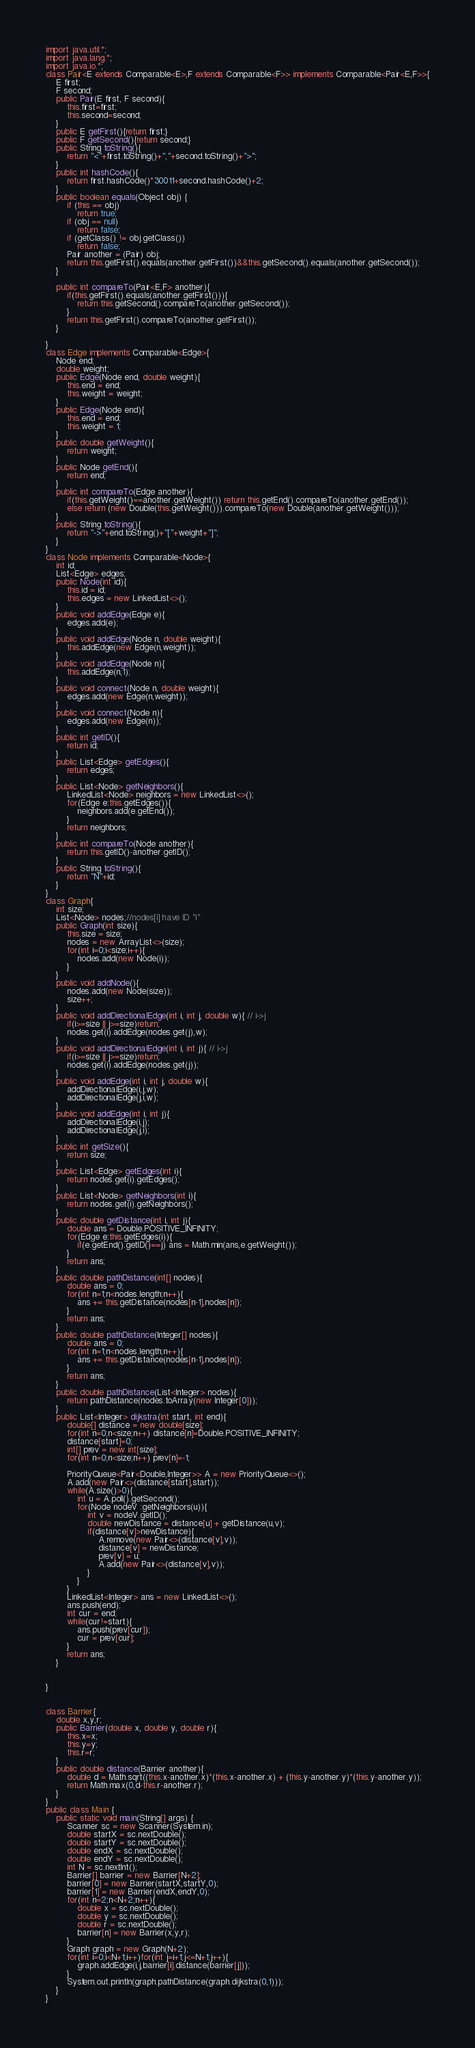<code> <loc_0><loc_0><loc_500><loc_500><_Java_>import java.util.*;
import java.lang.*;
import java.io.*;
class Pair<E extends Comparable<E>,F extends Comparable<F>> implements Comparable<Pair<E,F>>{
    E first;
    F second;
    public Pair(E first, F second){
        this.first=first;
        this.second=second;
    }
    public E getFirst(){return first;}
    public F getSecond(){return second;}
    public String toString(){
        return "<"+first.toString()+","+second.toString()+">";
    }
    public int hashCode(){
        return first.hashCode()*30011+second.hashCode()+2;
    }
    public boolean equals(Object obj) {
        if (this == obj)
            return true;
        if (obj == null)
            return false;
        if (getClass() != obj.getClass())
            return false;
        Pair another = (Pair) obj;
        return this.getFirst().equals(another.getFirst())&&this.getSecond().equals(another.getSecond());
    }
    
    public int compareTo(Pair<E,F> another){
        if(this.getFirst().equals(another.getFirst())){
        	return this.getSecond().compareTo(another.getSecond());
        }
        return this.getFirst().compareTo(another.getFirst());
    }
    
}
class Edge implements Comparable<Edge>{
    Node end;
    double weight;
    public Edge(Node end, double weight){
        this.end = end;
        this.weight = weight;
    }
    public Edge(Node end){
        this.end = end;
        this.weight = 1;
    }
    public double getWeight(){
        return weight;
    }
    public Node getEnd(){
        return end;
    }
    public int compareTo(Edge another){
        if(this.getWeight()==another.getWeight()) return this.getEnd().compareTo(another.getEnd());
        else return (new Double(this.getWeight())).compareTo(new Double(another.getWeight()));
    }
    public String toString(){
        return "->"+end.toString()+"["+weight+"]";
    }
}
class Node implements Comparable<Node>{
    int id;
    List<Edge> edges;
    public Node(int id){
        this.id = id;
        this.edges = new LinkedList<>();
    }
    public void addEdge(Edge e){
        edges.add(e);
    }
    public void addEdge(Node n, double weight){
        this.addEdge(new Edge(n,weight));
    }
    public void addEdge(Node n){
        this.addEdge(n,1);
    }
    public void connect(Node n, double weight){
        edges.add(new Edge(n,weight));
    }
    public void connect(Node n){
        edges.add(new Edge(n));
    }
    public int getID(){
        return id;
    }
    public List<Edge> getEdges(){
        return edges;
    }
    public List<Node> getNeighbors(){
        LinkedList<Node> neighbors = new LinkedList<>();
        for(Edge e:this.getEdges()){
        	neighbors.add(e.getEnd());
        }
        return neighbors;
    }
    public int compareTo(Node another){
        return this.getID()-another.getID();
    }
    public String toString(){
        return "N"+id;
    }
}
class Graph{
    int size;
    List<Node> nodes;//nodes[i] have ID "i"
    public Graph(int size){
        this.size = size;
        nodes = new ArrayList<>(size);
        for(int i=0;i<size;i++){
        	nodes.add(new Node(i));
        }
    }
    public void addNode(){
        nodes.add(new Node(size));
        size++;
    }
    public void addDirectionalEdge(int i, int j, double w){ // i->j
        if(i>=size || j>=size)return;
        nodes.get(i).addEdge(nodes.get(j),w);
    }
    public void addDirectionalEdge(int i, int j){ // i->j
        if(i>=size || j>=size)return;
        nodes.get(i).addEdge(nodes.get(j));
    }
    public void addEdge(int i, int j, double w){
        addDirectionalEdge(i,j,w);
        addDirectionalEdge(j,i,w);
    }
    public void addEdge(int i, int j){
        addDirectionalEdge(i,j);
        addDirectionalEdge(j,i);
    }
    public int getSize(){
        return size;
    }
    public List<Edge> getEdges(int i){
        return nodes.get(i).getEdges();
    }
    public List<Node> getNeighbors(int i){
        return nodes.get(i).getNeighbors();
    }
    public double getDistance(int i, int j){
        double ans = Double.POSITIVE_INFINITY;
        for(Edge e:this.getEdges(i)){
        	if(e.getEnd().getID()==j) ans = Math.min(ans,e.getWeight());
        }
        return ans;
    }
    public double pathDistance(int[] nodes){
        double ans = 0;
        for(int n=1;n<nodes.length;n++){
        	ans += this.getDistance(nodes[n-1],nodes[n]);
        }
        return ans;
    }
    public double pathDistance(Integer[] nodes){
        double ans = 0;
        for(int n=1;n<nodes.length;n++){
        	ans += this.getDistance(nodes[n-1],nodes[n]);
        }
        return ans;
    }
    public double pathDistance(List<Integer> nodes){
        return pathDistance(nodes.toArray(new Integer[0]));
    }
    public List<Integer> dijkstra(int start, int end){
        double[] distance = new double[size];
        for(int n=0;n<size;n++) distance[n]=Double.POSITIVE_INFINITY;
        distance[start]=0;
        int[] prev = new int[size];
        for(int n=0;n<size;n++) prev[n]=-1;
        
        PriorityQueue<Pair<Double,Integer>> A = new PriorityQueue<>();
        A.add(new Pair<>(distance[start],start));
        while(A.size()>0){
        	int u = A.poll().getSecond();
        	for(Node nodeV :getNeighbors(u)){
        	    int v = nodeV.getID();
        	    double newDistance = distance[u] + getDistance(u,v);
        	    if(distance[v]>newDistance){
        	        A.remove(new Pair<>(distance[v],v));
        	        distance[v] = newDistance;
        	        prev[v] = u;
        	        A.add(new Pair<>(distance[v],v));
        	    }
        	}
        }
        LinkedList<Integer> ans = new LinkedList<>();
        ans.push(end);
        int cur = end;
        while(cur!=start){
        	ans.push(prev[cur]);
        	cur = prev[cur];
        }
        return ans;
    }
    
    
}


class Barrier{
    double x,y,r;
    public Barrier(double x, double y, double r){
        this.x=x;
        this.y=y;
        this.r=r;
    }
    public double distance(Barrier another){
        double d = Math.sqrt((this.x-another.x)*(this.x-another.x) + (this.y-another.y)*(this.y-another.y));
        return Math.max(0,d-this.r-another.r);
    }
}
public class Main {
    public static void main(String[] args) {
        Scanner sc = new Scanner(System.in);
        double startX = sc.nextDouble();
        double startY = sc.nextDouble();
        double endX = sc.nextDouble();
        double endY = sc.nextDouble();
        int N = sc.nextInt();
        Barrier[] barrier = new Barrier[N+2];
        barrier[0] = new Barrier(startX,startY,0);
        barrier[1] = new Barrier(endX,endY,0);
        for(int n=2;n<N+2;n++){
        	double x = sc.nextDouble();
        	double y = sc.nextDouble();
        	double r = sc.nextDouble();
        	barrier[n] = new Barrier(x,y,r);
        }
        Graph graph = new Graph(N+2);
        for(int i=0;i<N+1;i++)for(int j=i+1;j<=N+1;j++){
        	graph.addEdge(i,j,barrier[i].distance(barrier[j]));
        }
        System.out.println(graph.pathDistance(graph.dijkstra(0,1)));
    }
}
</code> 